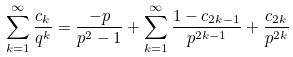Convert formula to latex. <formula><loc_0><loc_0><loc_500><loc_500>\sum _ { k = 1 } ^ { \infty } \frac { c _ { k } } { q ^ { k } } = \frac { - p } { p ^ { 2 } - 1 } + \sum _ { k = 1 } ^ { \infty } \frac { 1 - c _ { 2 k - 1 } } { p ^ { 2 k - 1 } } + \frac { c _ { 2 k } } { p ^ { 2 k } }</formula> 